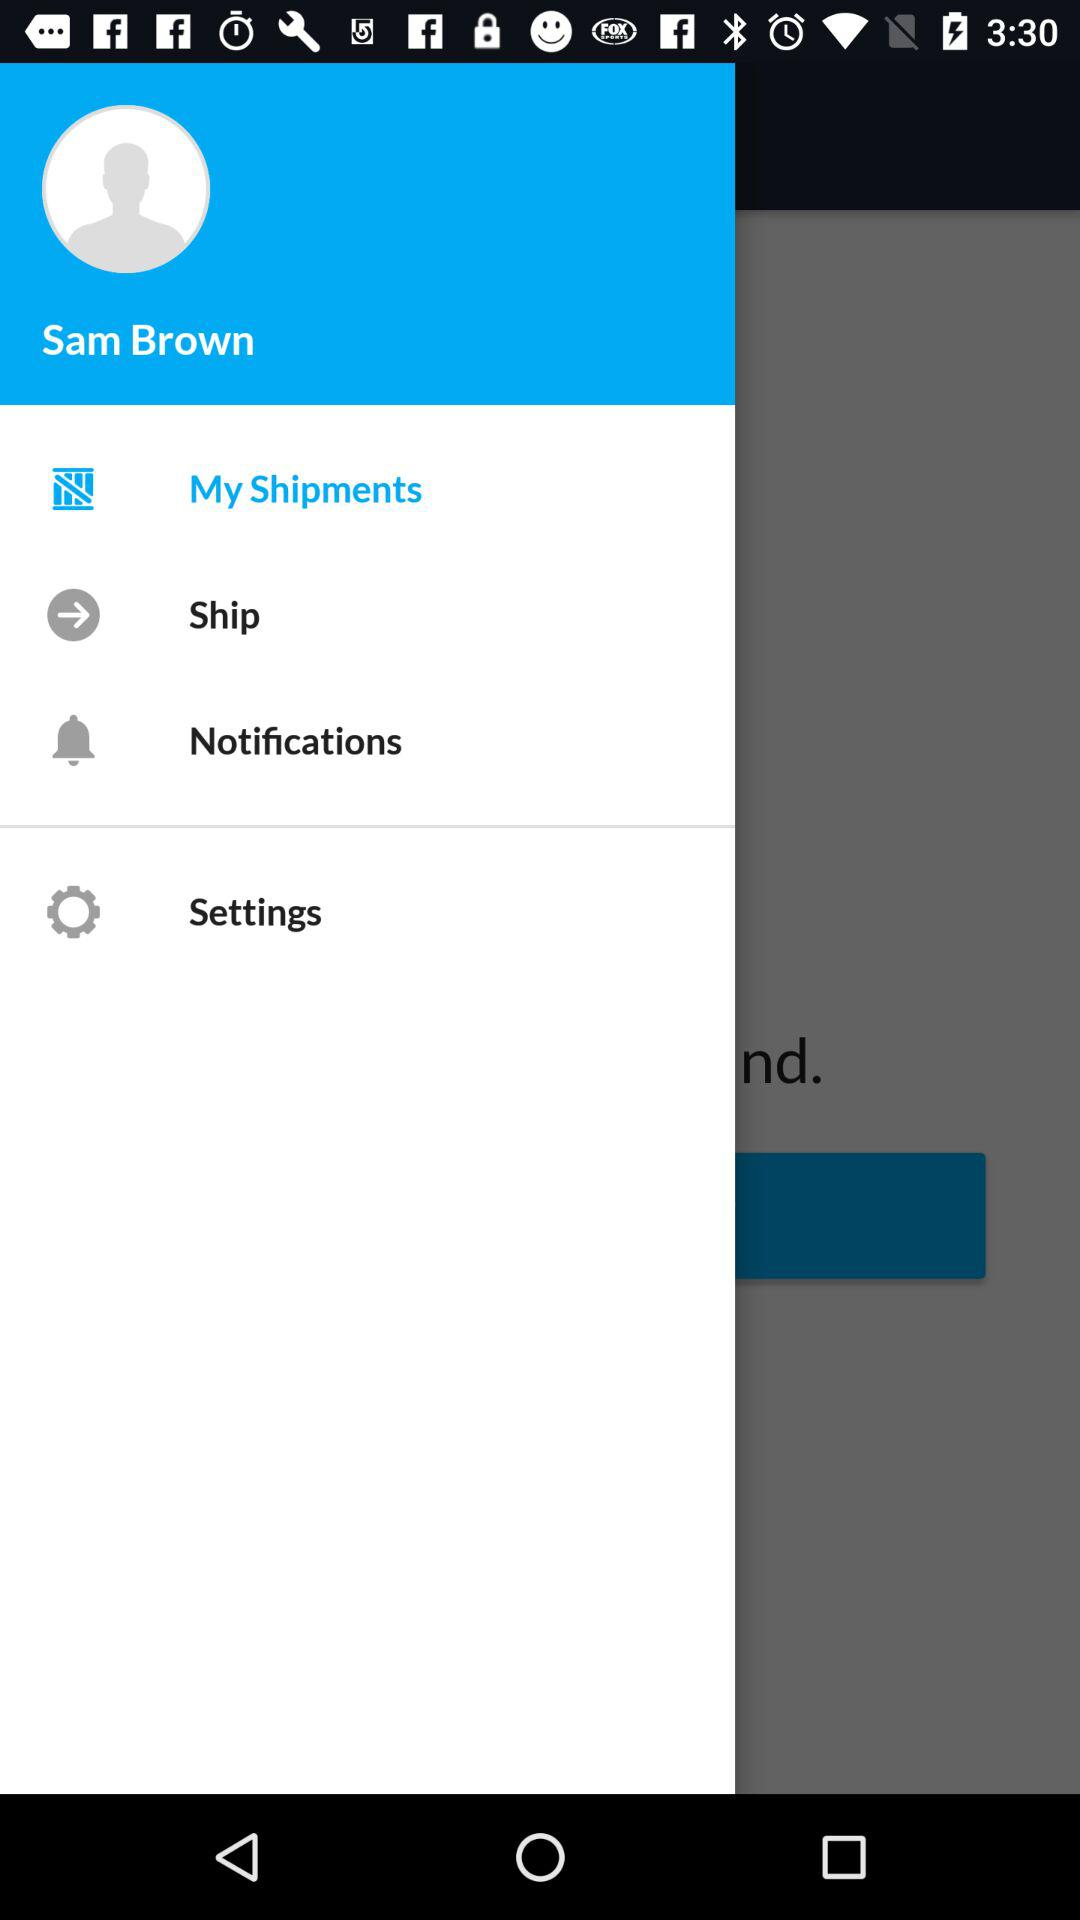What is the name of the user? The name of the user is Sam Brown. 